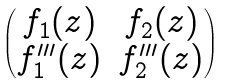Convert formula to latex. <formula><loc_0><loc_0><loc_500><loc_500>\begin{pmatrix} f _ { 1 } ( z ) & f _ { 2 } ( z ) \\ f ^ { \prime \prime \prime } _ { 1 } ( z ) & f ^ { \prime \prime \prime } _ { 2 } ( z ) \end{pmatrix}</formula> 